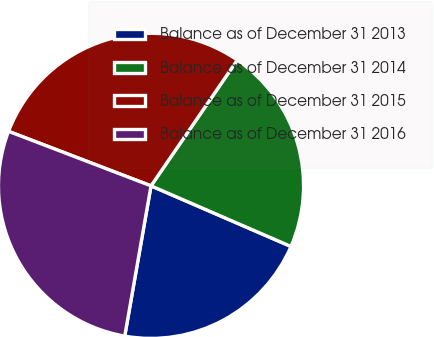Convert chart. <chart><loc_0><loc_0><loc_500><loc_500><pie_chart><fcel>Balance as of December 31 2013<fcel>Balance as of December 31 2014<fcel>Balance as of December 31 2015<fcel>Balance as of December 31 2016<nl><fcel>21.25%<fcel>21.94%<fcel>28.75%<fcel>28.06%<nl></chart> 